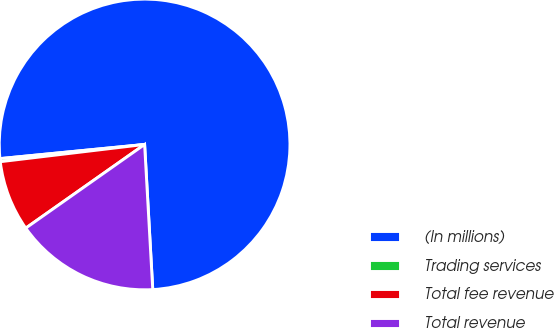Convert chart. <chart><loc_0><loc_0><loc_500><loc_500><pie_chart><fcel>(In millions)<fcel>Trading services<fcel>Total fee revenue<fcel>Total revenue<nl><fcel>75.66%<fcel>0.34%<fcel>7.87%<fcel>16.13%<nl></chart> 